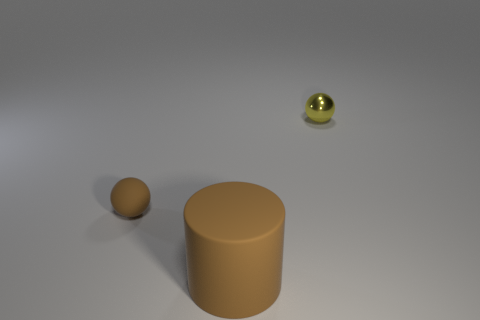Add 2 brown rubber cylinders. How many objects exist? 5 Subtract all spheres. How many objects are left? 1 Subtract 0 gray blocks. How many objects are left? 3 Subtract all tiny yellow things. Subtract all tiny red matte cylinders. How many objects are left? 2 Add 3 small things. How many small things are left? 5 Add 1 metallic things. How many metallic things exist? 2 